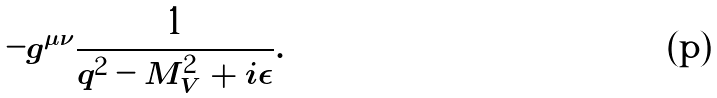<formula> <loc_0><loc_0><loc_500><loc_500>- g ^ { \mu \nu } \frac { 1 } { q ^ { 2 } - M _ { V } ^ { 2 } + i \epsilon } .</formula> 